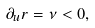<formula> <loc_0><loc_0><loc_500><loc_500>\partial _ { u } r = \nu < 0 ,</formula> 